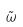<formula> <loc_0><loc_0><loc_500><loc_500>\tilde { \omega }</formula> 